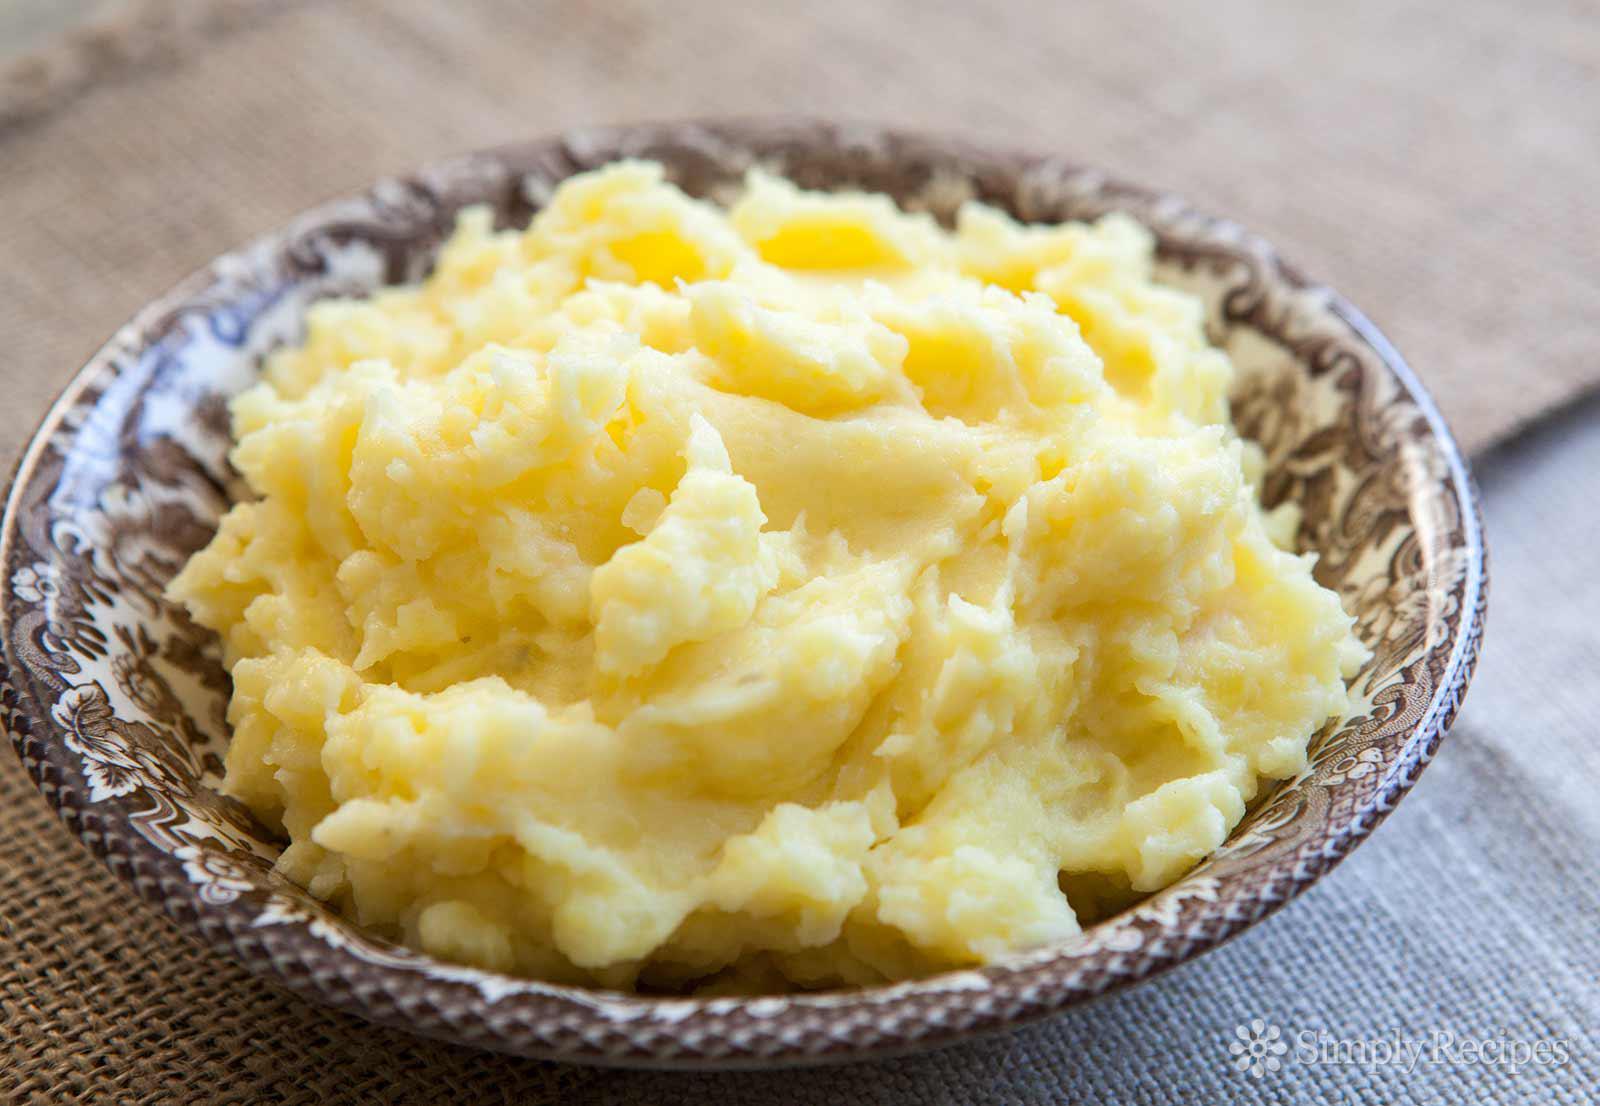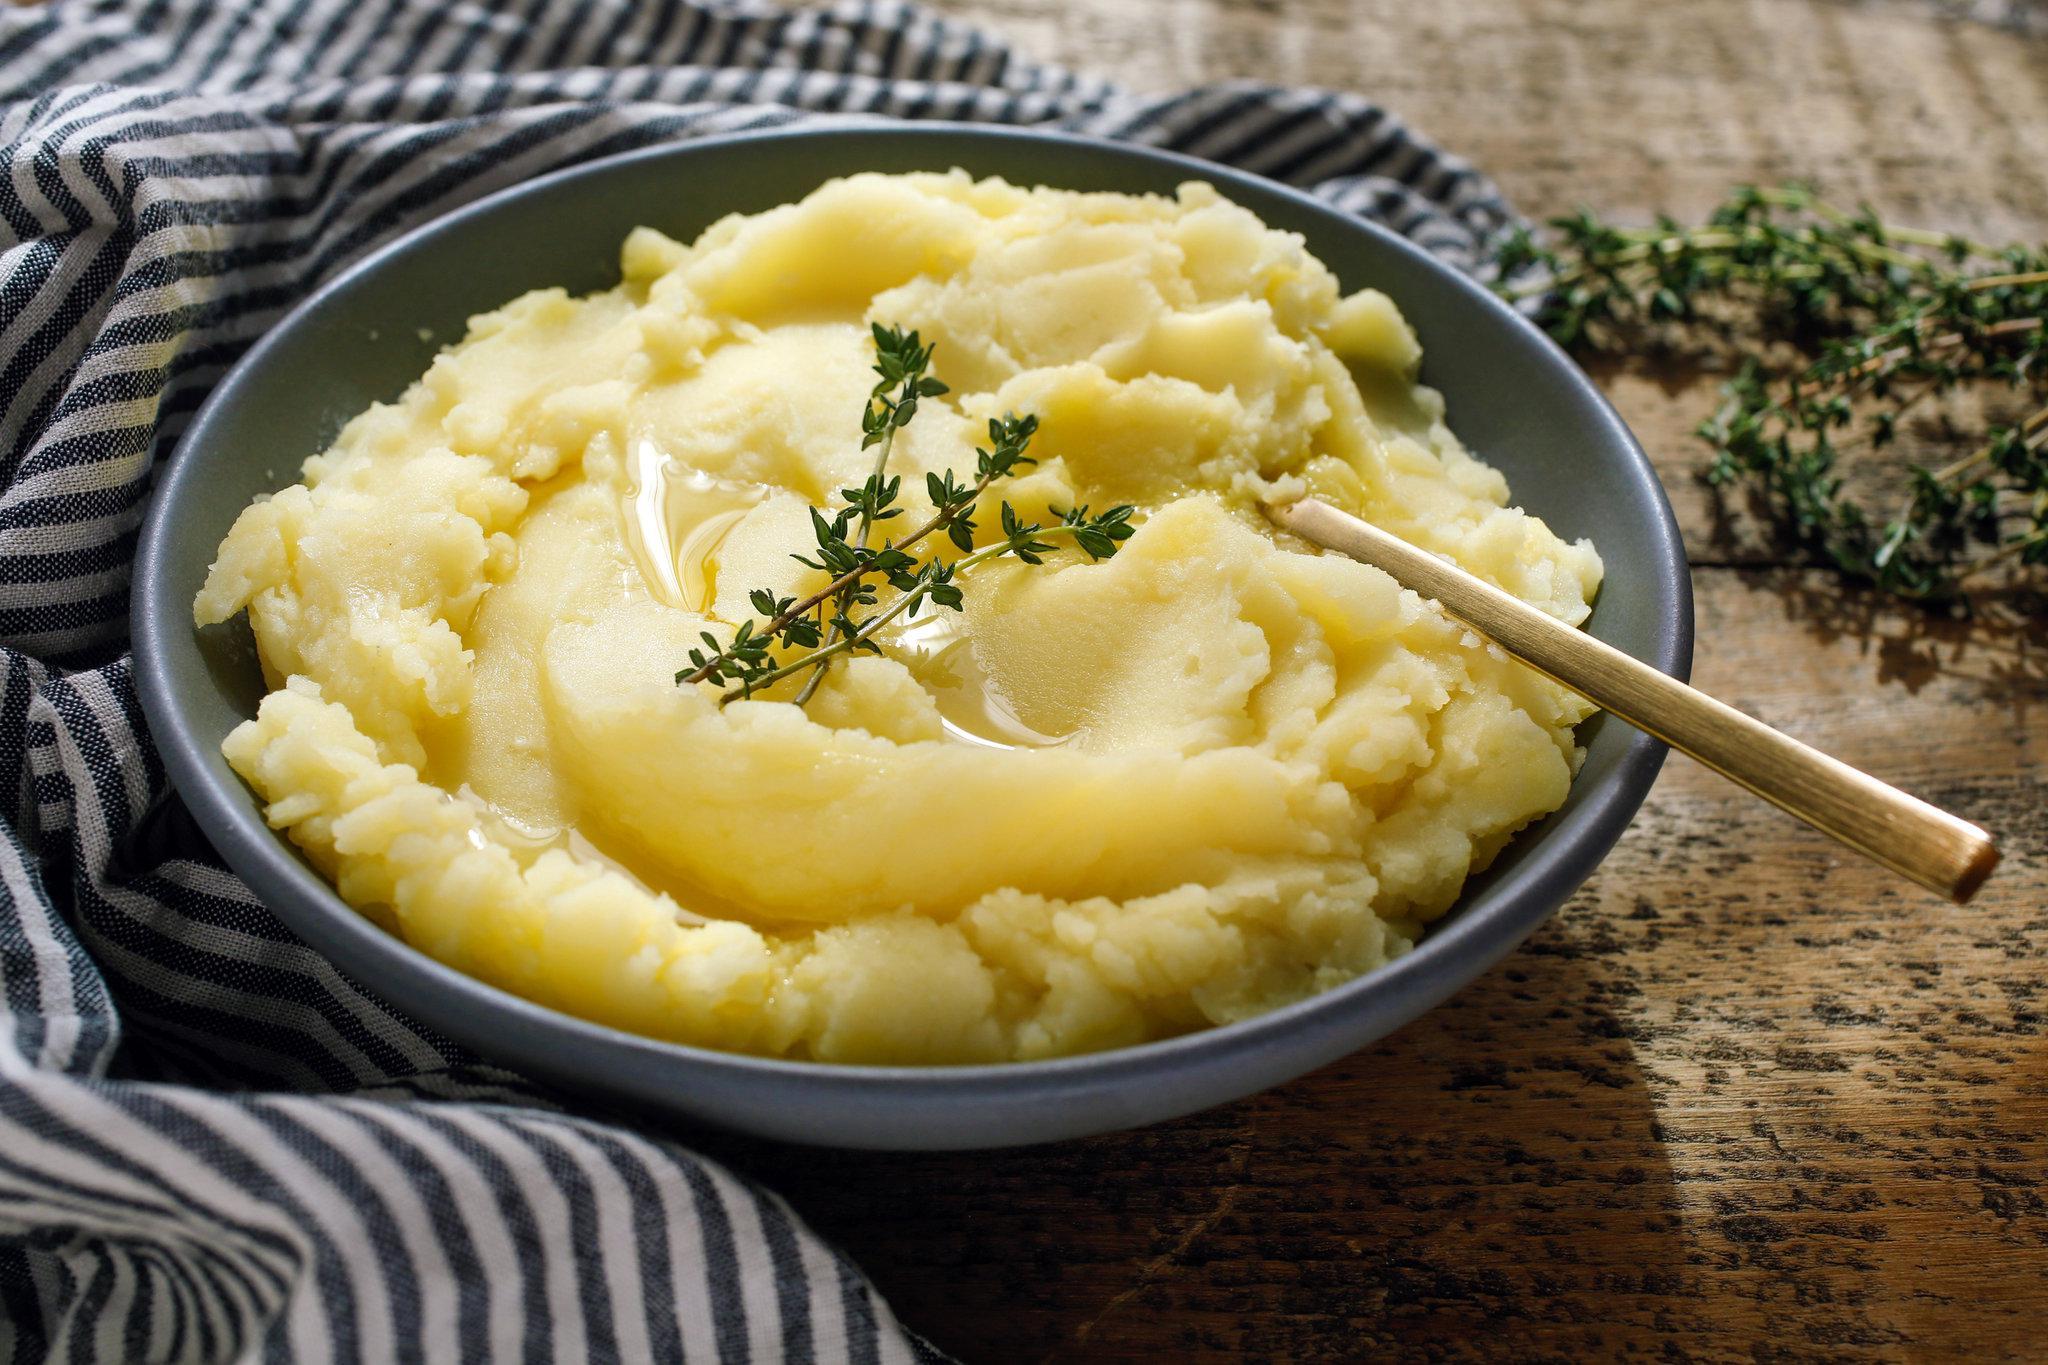The first image is the image on the left, the second image is the image on the right. Examine the images to the left and right. Is the description "One of the bowls is green" accurate? Answer yes or no. No. 